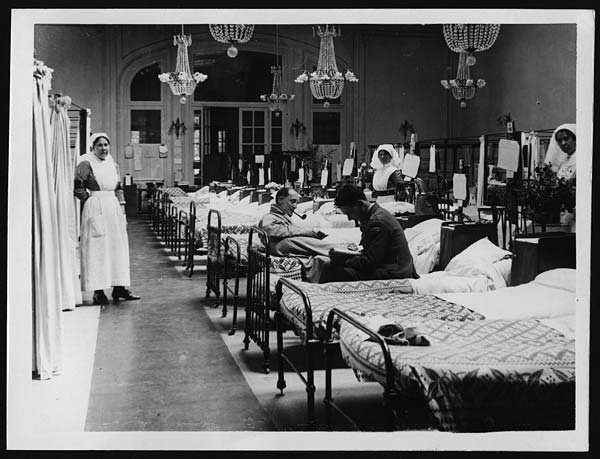Describe the objects in this image and their specific colors. I can see bed in black, darkgray, lightgray, and gray tones, bed in black, lightgray, darkgray, and gray tones, people in black, lightgray, darkgray, and gray tones, bed in black, lightgray, darkgray, and gray tones, and people in black, gray, darkgray, and lightgray tones in this image. 